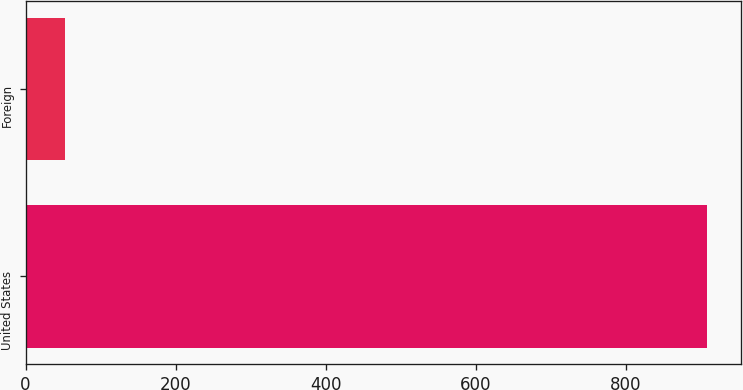Convert chart to OTSL. <chart><loc_0><loc_0><loc_500><loc_500><bar_chart><fcel>United States<fcel>Foreign<nl><fcel>909.2<fcel>53.2<nl></chart> 